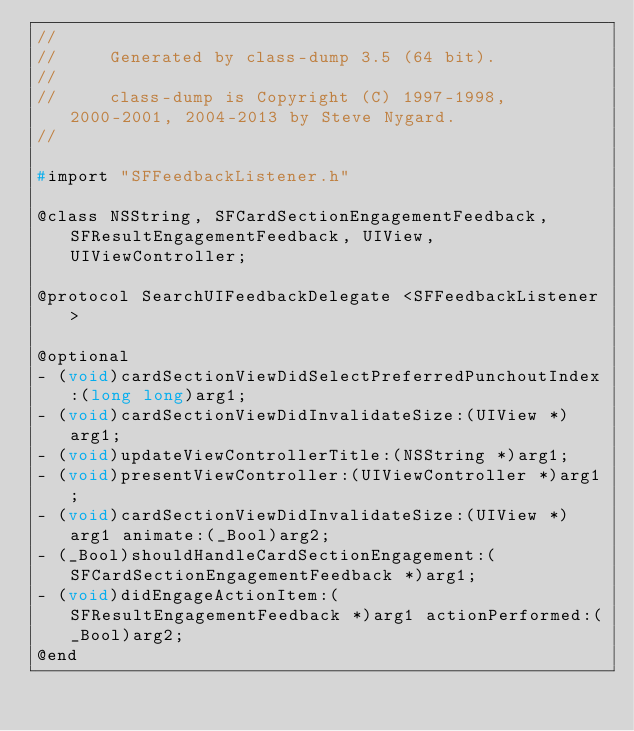Convert code to text. <code><loc_0><loc_0><loc_500><loc_500><_C_>//
//     Generated by class-dump 3.5 (64 bit).
//
//     class-dump is Copyright (C) 1997-1998, 2000-2001, 2004-2013 by Steve Nygard.
//

#import "SFFeedbackListener.h"

@class NSString, SFCardSectionEngagementFeedback, SFResultEngagementFeedback, UIView, UIViewController;

@protocol SearchUIFeedbackDelegate <SFFeedbackListener>

@optional
- (void)cardSectionViewDidSelectPreferredPunchoutIndex:(long long)arg1;
- (void)cardSectionViewDidInvalidateSize:(UIView *)arg1;
- (void)updateViewControllerTitle:(NSString *)arg1;
- (void)presentViewController:(UIViewController *)arg1;
- (void)cardSectionViewDidInvalidateSize:(UIView *)arg1 animate:(_Bool)arg2;
- (_Bool)shouldHandleCardSectionEngagement:(SFCardSectionEngagementFeedback *)arg1;
- (void)didEngageActionItem:(SFResultEngagementFeedback *)arg1 actionPerformed:(_Bool)arg2;
@end

</code> 